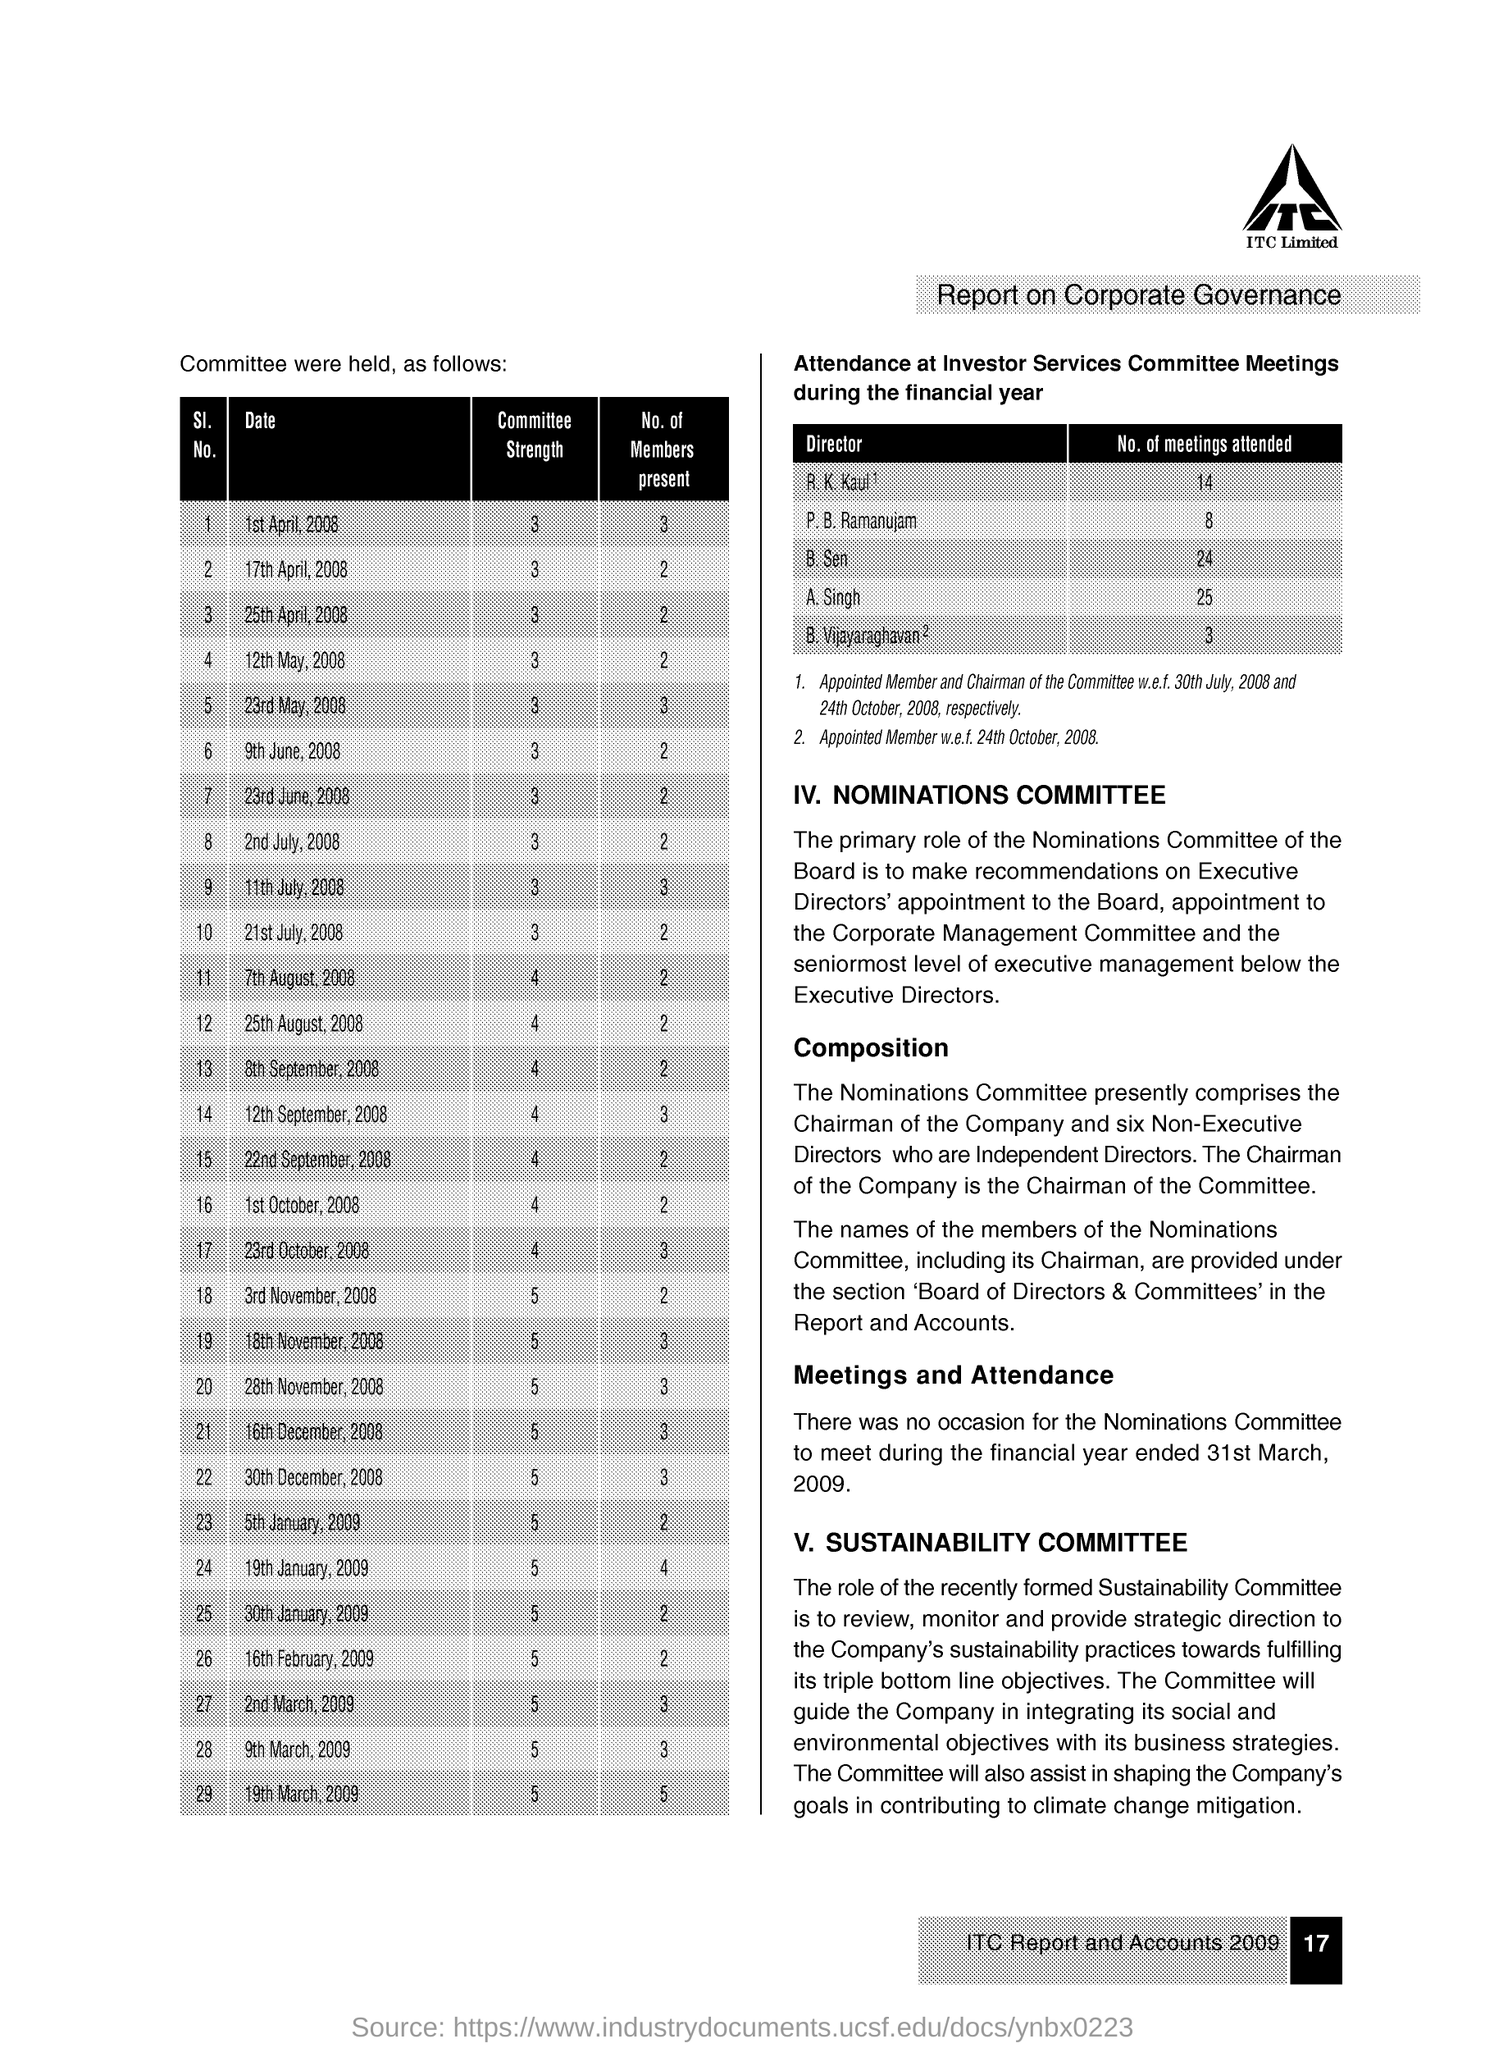Indicate a few pertinent items in this graphic. The B. Sen attended 24 meetings. 